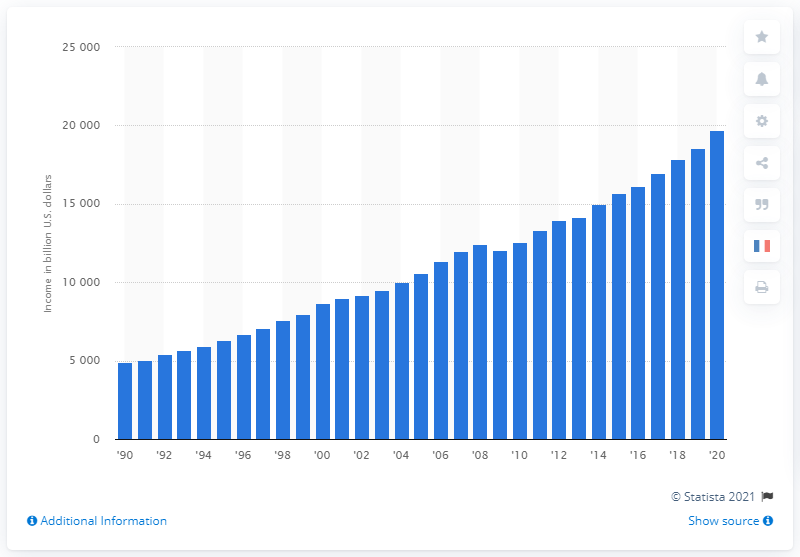Point out several critical features in this image. Personal income increased to $19,679.72 in 2020. 